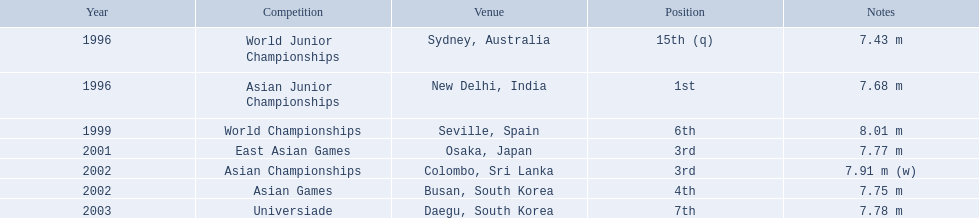Which competition did huang le achieve 3rd place? East Asian Games. Which competition did he achieve 4th place? Asian Games. When did he achieve 1st place? Asian Junior Championships. What are all the tournaments? World Junior Championships, Asian Junior Championships, World Championships, East Asian Games, Asian Championships, Asian Games, Universiade. What were his standings in these tournaments? 15th (q), 1st, 6th, 3rd, 3rd, 4th, 7th. And during which tournament did he secure 1st place? Asian Junior Championships. 